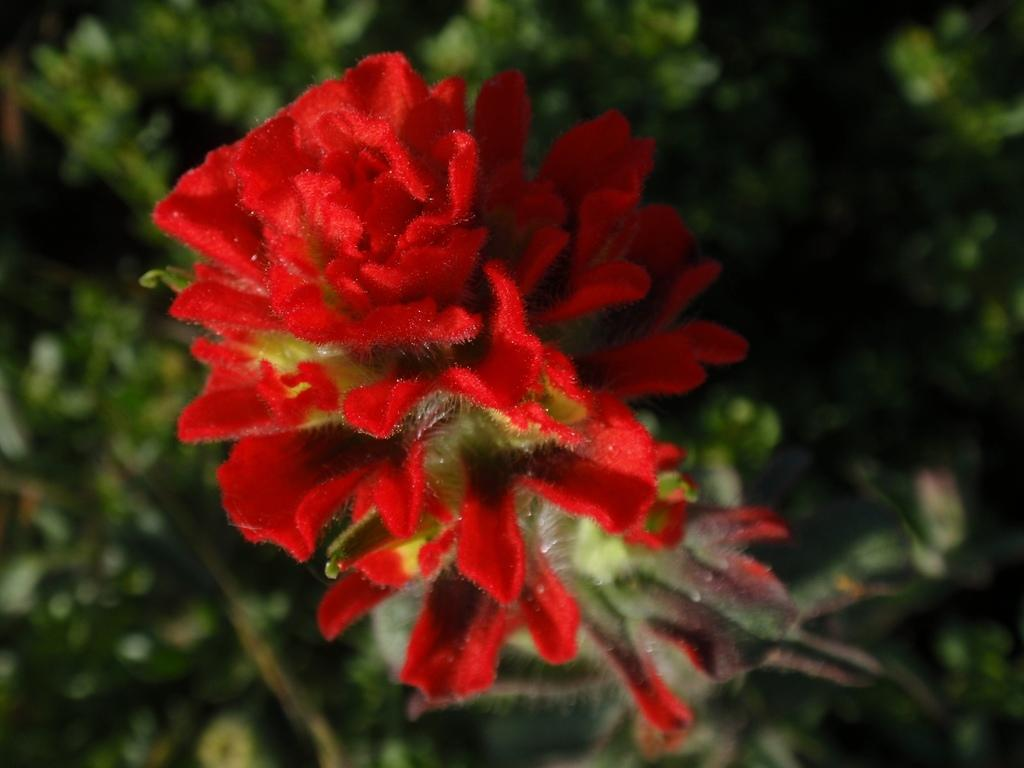What is the main subject of the image? The main subject of the image is flowers. Can you describe the flowers in the image? The flowers are red in color. What else can be seen in the background of the image? There are plants in the background of the image. What type of vest is the beginner wearing while hanging the ornament in the image? There is no person, vest, or ornament present in the image; it only features flowers and plants. 